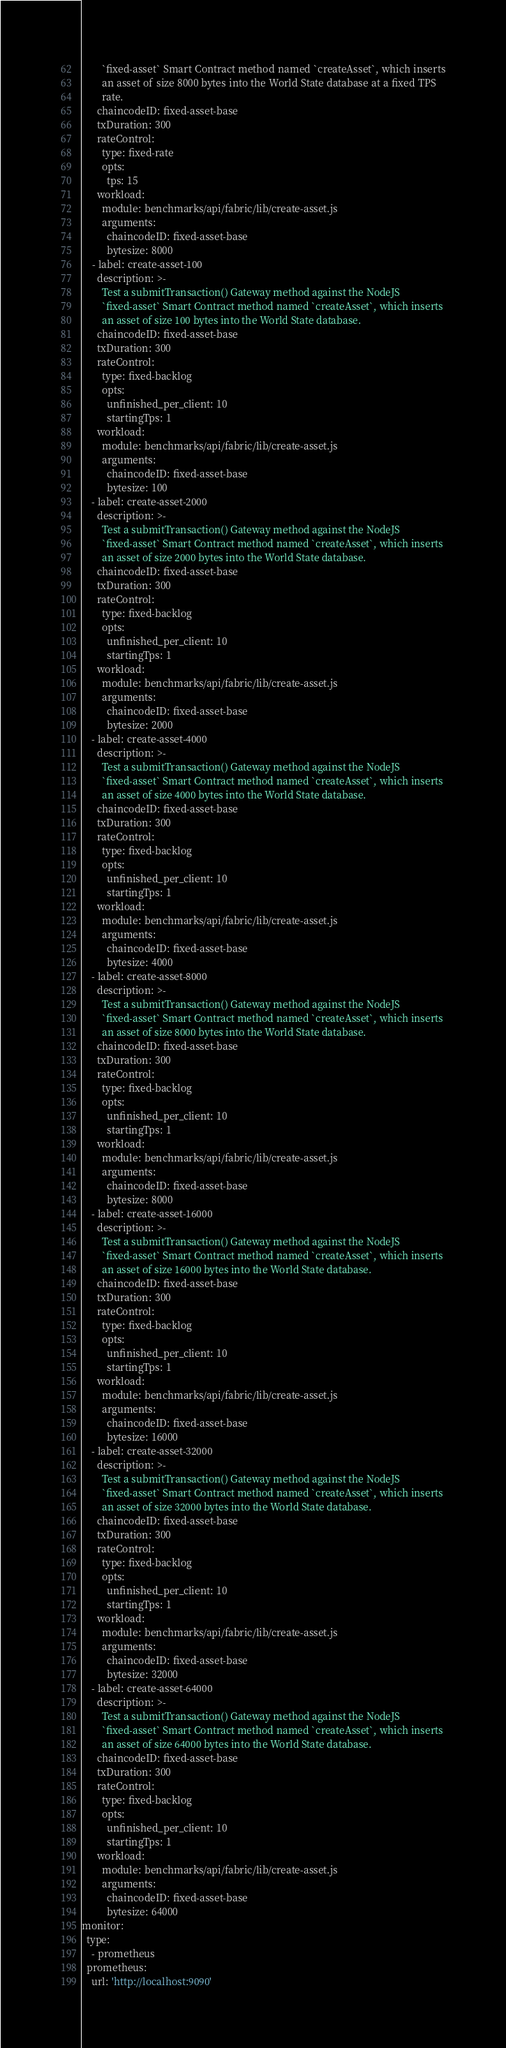<code> <loc_0><loc_0><loc_500><loc_500><_YAML_>        `fixed-asset` Smart Contract method named `createAsset`, which inserts
        an asset of size 8000 bytes into the World State database at a fixed TPS
        rate.
      chaincodeID: fixed-asset-base
      txDuration: 300
      rateControl:
        type: fixed-rate
        opts:
          tps: 15
      workload:
        module: benchmarks/api/fabric/lib/create-asset.js
        arguments:
          chaincodeID: fixed-asset-base
          bytesize: 8000
    - label: create-asset-100
      description: >-
        Test a submitTransaction() Gateway method against the NodeJS
        `fixed-asset` Smart Contract method named `createAsset`, which inserts
        an asset of size 100 bytes into the World State database.
      chaincodeID: fixed-asset-base
      txDuration: 300
      rateControl:
        type: fixed-backlog
        opts:
          unfinished_per_client: 10
          startingTps: 1
      workload:
        module: benchmarks/api/fabric/lib/create-asset.js
        arguments:
          chaincodeID: fixed-asset-base
          bytesize: 100
    - label: create-asset-2000
      description: >-
        Test a submitTransaction() Gateway method against the NodeJS
        `fixed-asset` Smart Contract method named `createAsset`, which inserts
        an asset of size 2000 bytes into the World State database.
      chaincodeID: fixed-asset-base
      txDuration: 300
      rateControl:
        type: fixed-backlog
        opts:
          unfinished_per_client: 10
          startingTps: 1
      workload:
        module: benchmarks/api/fabric/lib/create-asset.js
        arguments:
          chaincodeID: fixed-asset-base
          bytesize: 2000
    - label: create-asset-4000
      description: >-
        Test a submitTransaction() Gateway method against the NodeJS
        `fixed-asset` Smart Contract method named `createAsset`, which inserts
        an asset of size 4000 bytes into the World State database.
      chaincodeID: fixed-asset-base
      txDuration: 300
      rateControl:
        type: fixed-backlog
        opts:
          unfinished_per_client: 10
          startingTps: 1
      workload:
        module: benchmarks/api/fabric/lib/create-asset.js
        arguments:
          chaincodeID: fixed-asset-base
          bytesize: 4000
    - label: create-asset-8000
      description: >-
        Test a submitTransaction() Gateway method against the NodeJS
        `fixed-asset` Smart Contract method named `createAsset`, which inserts
        an asset of size 8000 bytes into the World State database.
      chaincodeID: fixed-asset-base
      txDuration: 300
      rateControl:
        type: fixed-backlog
        opts:
          unfinished_per_client: 10
          startingTps: 1
      workload:
        module: benchmarks/api/fabric/lib/create-asset.js
        arguments:
          chaincodeID: fixed-asset-base
          bytesize: 8000
    - label: create-asset-16000
      description: >-
        Test a submitTransaction() Gateway method against the NodeJS
        `fixed-asset` Smart Contract method named `createAsset`, which inserts
        an asset of size 16000 bytes into the World State database.
      chaincodeID: fixed-asset-base
      txDuration: 300
      rateControl:
        type: fixed-backlog
        opts:
          unfinished_per_client: 10
          startingTps: 1
      workload:
        module: benchmarks/api/fabric/lib/create-asset.js
        arguments:
          chaincodeID: fixed-asset-base
          bytesize: 16000
    - label: create-asset-32000
      description: >-
        Test a submitTransaction() Gateway method against the NodeJS
        `fixed-asset` Smart Contract method named `createAsset`, which inserts
        an asset of size 32000 bytes into the World State database.
      chaincodeID: fixed-asset-base
      txDuration: 300
      rateControl:
        type: fixed-backlog
        opts:
          unfinished_per_client: 10
          startingTps: 1
      workload:
        module: benchmarks/api/fabric/lib/create-asset.js
        arguments:
          chaincodeID: fixed-asset-base
          bytesize: 32000
    - label: create-asset-64000
      description: >-
        Test a submitTransaction() Gateway method against the NodeJS
        `fixed-asset` Smart Contract method named `createAsset`, which inserts
        an asset of size 64000 bytes into the World State database.
      chaincodeID: fixed-asset-base
      txDuration: 300
      rateControl:
        type: fixed-backlog
        opts:
          unfinished_per_client: 10
          startingTps: 1
      workload:
        module: benchmarks/api/fabric/lib/create-asset.js
        arguments:
          chaincodeID: fixed-asset-base
          bytesize: 64000
monitor:
  type:
    - prometheus
  prometheus:
    url: 'http://localhost:9090'</code> 